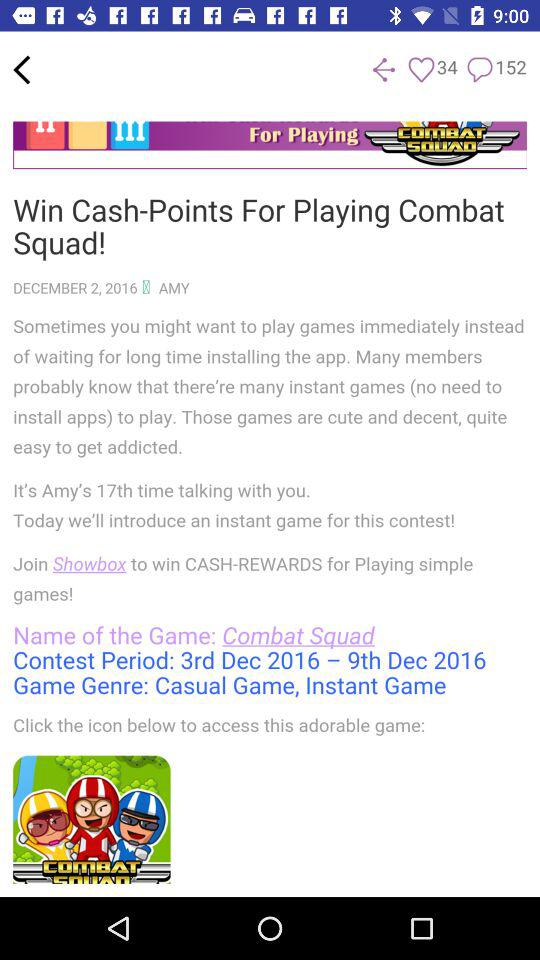What is the number of likes? The number of likes is 34. 